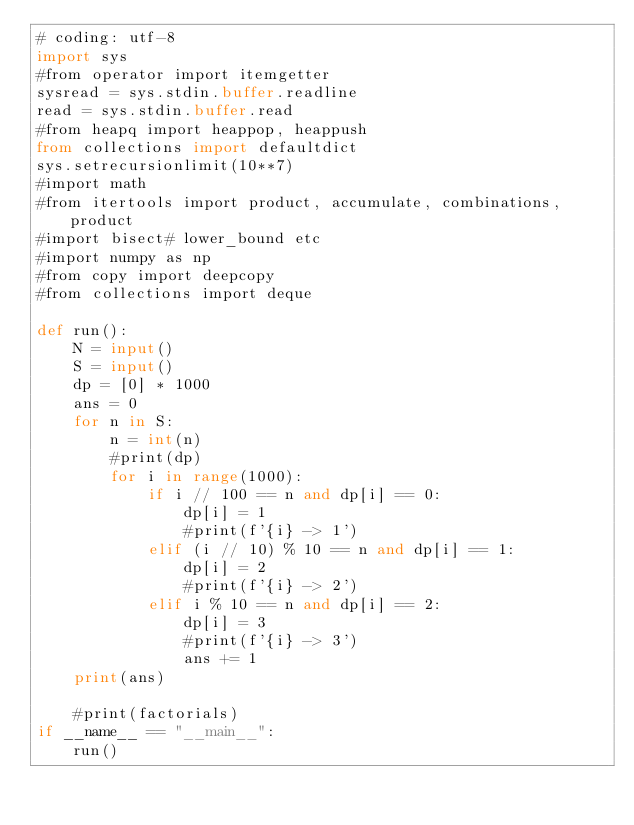Convert code to text. <code><loc_0><loc_0><loc_500><loc_500><_Python_># coding: utf-8
import sys
#from operator import itemgetter
sysread = sys.stdin.buffer.readline
read = sys.stdin.buffer.read
#from heapq import heappop, heappush
from collections import defaultdict
sys.setrecursionlimit(10**7)
#import math
#from itertools import product, accumulate, combinations, product
#import bisect# lower_bound etc
#import numpy as np
#from copy import deepcopy
#from collections import deque

def run():
    N = input()
    S = input()
    dp = [0] * 1000
    ans = 0
    for n in S:
        n = int(n)
        #print(dp)
        for i in range(1000):
            if i // 100 == n and dp[i] == 0:
                dp[i] = 1
                #print(f'{i} -> 1')
            elif (i // 10) % 10 == n and dp[i] == 1:
                dp[i] = 2
                #print(f'{i} -> 2')
            elif i % 10 == n and dp[i] == 2:
                dp[i] = 3
                #print(f'{i} -> 3')
                ans += 1
    print(ans)

    #print(factorials)
if __name__ == "__main__":
    run()</code> 